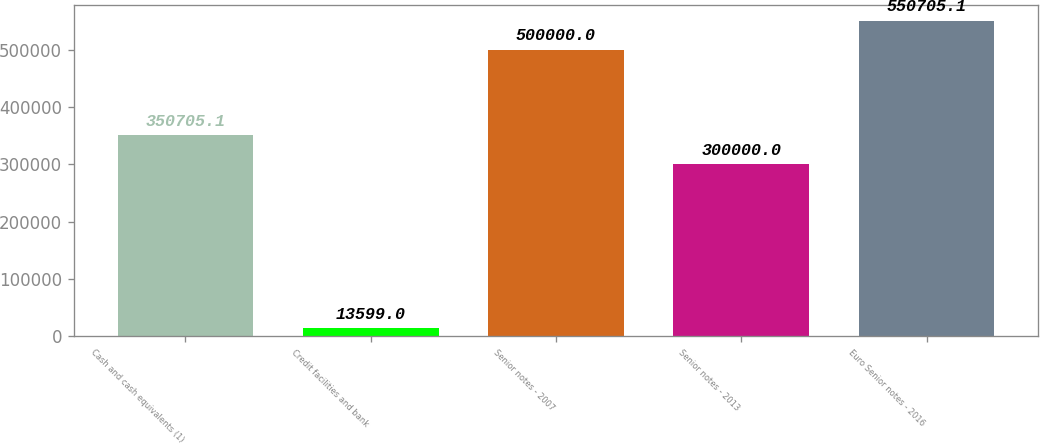<chart> <loc_0><loc_0><loc_500><loc_500><bar_chart><fcel>Cash and cash equivalents (1)<fcel>Credit facilities and bank<fcel>Senior notes - 2007<fcel>Senior notes - 2013<fcel>Euro Senior notes - 2016<nl><fcel>350705<fcel>13599<fcel>500000<fcel>300000<fcel>550705<nl></chart> 